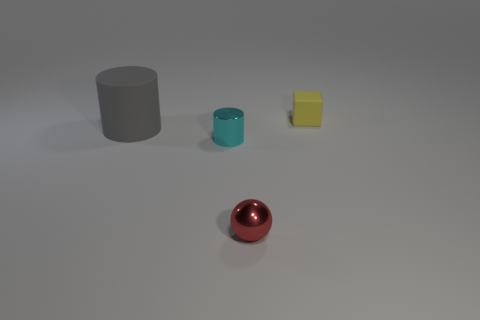Is there anything else that has the same size as the gray object?
Provide a succinct answer. No. Is the number of tiny cyan shiny things behind the tiny red sphere greater than the number of tiny gray rubber blocks?
Offer a terse response. Yes. What is the size of the red object that is made of the same material as the tiny cyan object?
Give a very brief answer. Small. How many spheres are the same color as the big object?
Your response must be concise. 0. Are there the same number of tiny cyan shiny things that are behind the small cyan cylinder and large gray cylinders on the left side of the large gray matte thing?
Keep it short and to the point. Yes. The matte thing that is to the right of the red object is what color?
Offer a terse response. Yellow. Are there the same number of large cylinders behind the big cylinder and big rubber cylinders?
Your answer should be very brief. No. What number of other things are the same shape as the cyan thing?
Make the answer very short. 1. There is a matte cylinder; how many small cubes are to the right of it?
Give a very brief answer. 1. What size is the object that is behind the cyan metallic cylinder and left of the yellow block?
Your response must be concise. Large. 